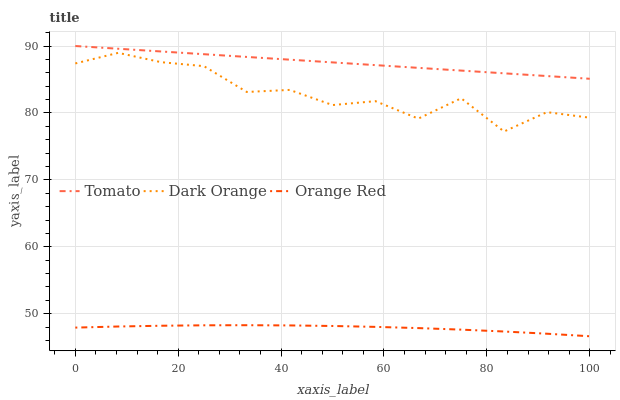Does Orange Red have the minimum area under the curve?
Answer yes or no. Yes. Does Tomato have the maximum area under the curve?
Answer yes or no. Yes. Does Dark Orange have the minimum area under the curve?
Answer yes or no. No. Does Dark Orange have the maximum area under the curve?
Answer yes or no. No. Is Tomato the smoothest?
Answer yes or no. Yes. Is Dark Orange the roughest?
Answer yes or no. Yes. Is Orange Red the smoothest?
Answer yes or no. No. Is Orange Red the roughest?
Answer yes or no. No. Does Orange Red have the lowest value?
Answer yes or no. Yes. Does Dark Orange have the lowest value?
Answer yes or no. No. Does Tomato have the highest value?
Answer yes or no. Yes. Does Dark Orange have the highest value?
Answer yes or no. No. Is Orange Red less than Dark Orange?
Answer yes or no. Yes. Is Dark Orange greater than Orange Red?
Answer yes or no. Yes. Does Orange Red intersect Dark Orange?
Answer yes or no. No. 